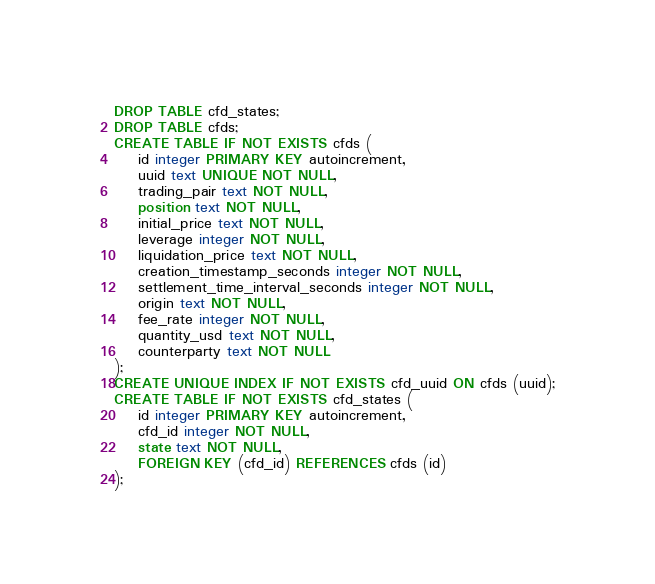Convert code to text. <code><loc_0><loc_0><loc_500><loc_500><_SQL_>DROP TABLE cfd_states;
DROP TABLE cfds;
CREATE TABLE IF NOT EXISTS cfds (
    id integer PRIMARY KEY autoincrement,
    uuid text UNIQUE NOT NULL,
    trading_pair text NOT NULL,
    position text NOT NULL,
    initial_price text NOT NULL,
    leverage integer NOT NULL,
    liquidation_price text NOT NULL,
    creation_timestamp_seconds integer NOT NULL,
    settlement_time_interval_seconds integer NOT NULL,
    origin text NOT NULL,
    fee_rate integer NOT NULL,
    quantity_usd text NOT NULL,
    counterparty text NOT NULL
);
CREATE UNIQUE INDEX IF NOT EXISTS cfd_uuid ON cfds (uuid);
CREATE TABLE IF NOT EXISTS cfd_states (
    id integer PRIMARY KEY autoincrement,
    cfd_id integer NOT NULL,
    state text NOT NULL,
    FOREIGN KEY (cfd_id) REFERENCES cfds (id)
);
</code> 